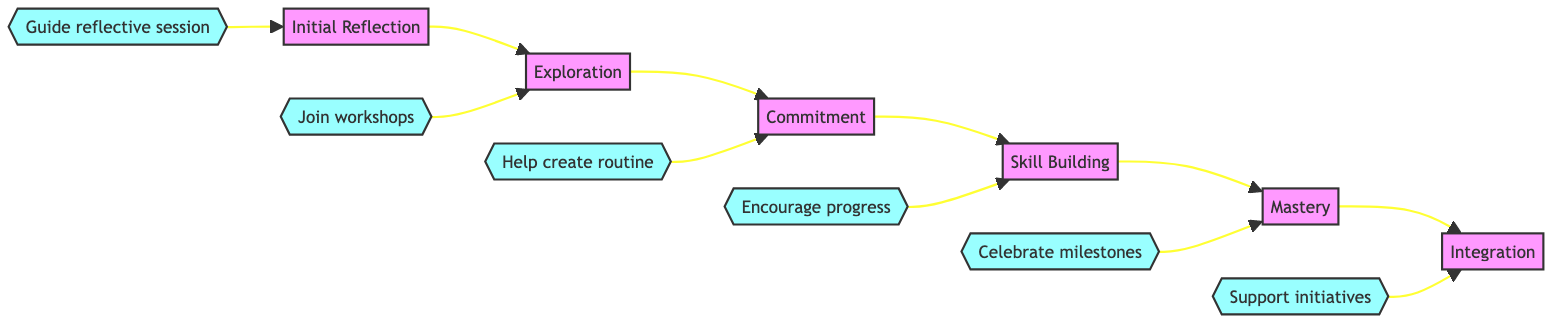What is the first step in the journey? The first step in the journey is labeled "Initial Reflection," which is indicated as the starting node in the flowchart.
Answer: Initial Reflection How many steps are there in the flowchart? The flowchart contains a total of six steps, which can be counted from the nodes outlined in the diagram.
Answer: Six What follows "Exploration" in the sequence? According to the flowchart's directional flow from one node to the next, "Commitment" directly follows "Exploration."
Answer: Commitment What action is associated with "Mastery"? The action linked with "Mastery" is "Celebrate milestones," which is explicitly mentioned as the persona's action connected to that step.
Answer: Celebrate milestones Which step comes before "Integration"? The step that comes before "Integration" is "Mastery," as indicated by the linear flow from one step to another leading to "Integration."
Answer: Mastery Which persona action is tied to the "Skill Building" step? The action associated with "Skill Building" is "Encourage progress," which is indicated clearly as the supportive action under that specific step.
Answer: Encourage progress How many persona actions are present in the flowchart? There are six persona actions depicted in the diagram, correlating with each of the six steps of the journey.
Answer: Six Which step requires dedicating regular time to chosen activities? The step that entails dedicating regular time to chosen activities is "Commitment," as noted in the description related to that node.
Answer: Commitment What significant skill-development activity is suggested in "Skill Building"? The significant activity suggested in "Skill Building" is "Enrolling in courses," indicated in the example provided for that step on the flowchart.
Answer: Enrolling in courses 